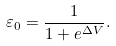<formula> <loc_0><loc_0><loc_500><loc_500>\varepsilon _ { 0 } = \frac { 1 } { 1 + e ^ { \Delta V } } .</formula> 